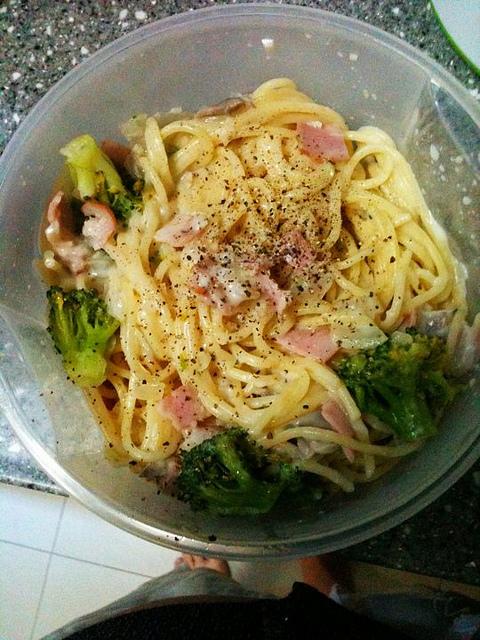Are there any worms in the bowl?
Keep it brief. No. Is the food tasty?
Short answer required. Yes. Is there any meat in the meal?
Be succinct. Yes. 